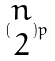Convert formula to latex. <formula><loc_0><loc_0><loc_500><loc_500>( \begin{matrix} n \\ 2 \end{matrix} ) p</formula> 